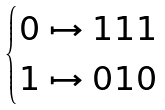<formula> <loc_0><loc_0><loc_500><loc_500>\begin{cases} 0 \mapsto 1 1 1 \\ 1 \mapsto 0 1 0 \end{cases}</formula> 